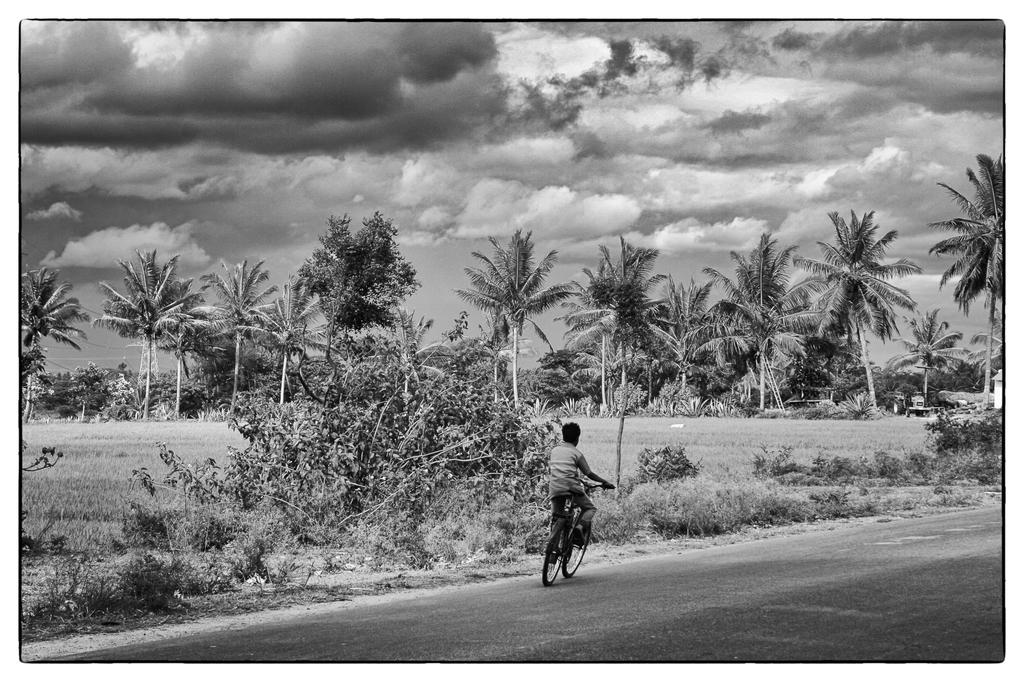Who is in the image? There is a boy in the image. What is the boy doing in the image? The boy is riding a bicycle. Where is the bicycle located? The bicycle is on a road. What can be seen on the left side of the image? There are trees and farms on the left side of the image. How would you describe the sky in the image? The sky is filled with clouds. What type of love can be seen in the image? There is no love present in the image; it features a boy riding a bicycle on a road. What is the chin of the person in the image like? There is no person in the image, only a boy riding a bicycle. 